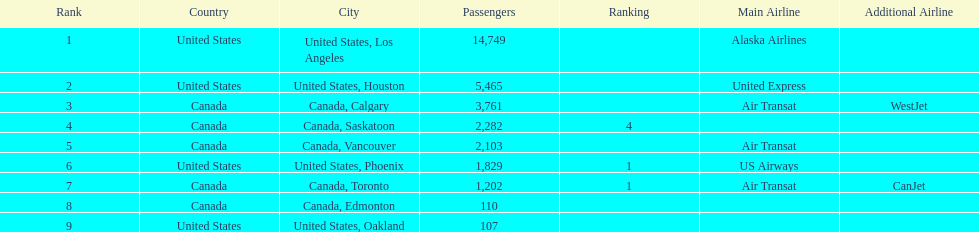What is the average number of passengers in the united states? 5537.5. 